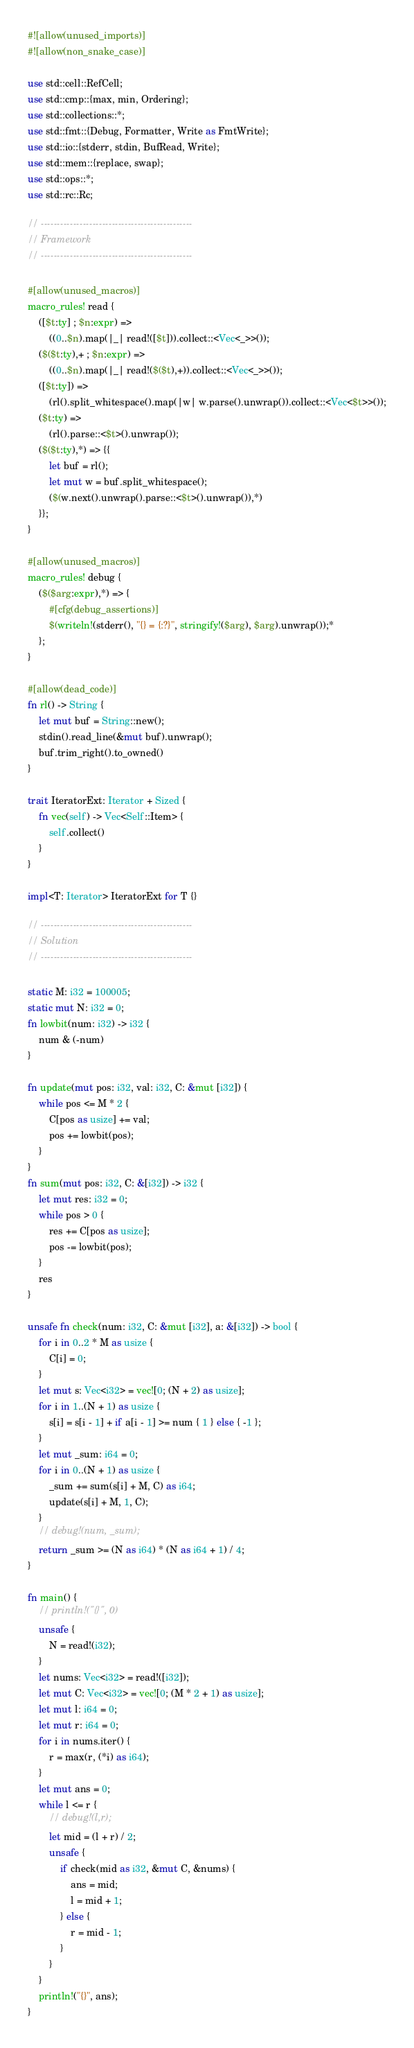<code> <loc_0><loc_0><loc_500><loc_500><_Rust_>#![allow(unused_imports)]
#![allow(non_snake_case)]

use std::cell::RefCell;
use std::cmp::{max, min, Ordering};
use std::collections::*;
use std::fmt::{Debug, Formatter, Write as FmtWrite};
use std::io::{stderr, stdin, BufRead, Write};
use std::mem::{replace, swap};
use std::ops::*;
use std::rc::Rc;

// -----------------------------------------------
// Framework
// -----------------------------------------------

#[allow(unused_macros)]
macro_rules! read {
    ([$t:ty] ; $n:expr) =>
        ((0..$n).map(|_| read!([$t])).collect::<Vec<_>>());
    ($($t:ty),+ ; $n:expr) =>
        ((0..$n).map(|_| read!($($t),+)).collect::<Vec<_>>());
    ([$t:ty]) =>
        (rl().split_whitespace().map(|w| w.parse().unwrap()).collect::<Vec<$t>>());
    ($t:ty) =>
        (rl().parse::<$t>().unwrap());
    ($($t:ty),*) => {{
        let buf = rl();
        let mut w = buf.split_whitespace();
        ($(w.next().unwrap().parse::<$t>().unwrap()),*)
    }};
}

#[allow(unused_macros)]
macro_rules! debug {
    ($($arg:expr),*) => {
        #[cfg(debug_assertions)]
        $(writeln!(stderr(), "{} = {:?}", stringify!($arg), $arg).unwrap());*
    };
}

#[allow(dead_code)]
fn rl() -> String {
    let mut buf = String::new();
    stdin().read_line(&mut buf).unwrap();
    buf.trim_right().to_owned()
}

trait IteratorExt: Iterator + Sized {
    fn vec(self) -> Vec<Self::Item> {
        self.collect()
    }
}

impl<T: Iterator> IteratorExt for T {}

// -----------------------------------------------
// Solution
// -----------------------------------------------

static M: i32 = 100005;
static mut N: i32 = 0;
fn lowbit(num: i32) -> i32 {
    num & (-num)
}

fn update(mut pos: i32, val: i32, C: &mut [i32]) {
    while pos <= M * 2 {
        C[pos as usize] += val;
        pos += lowbit(pos);
    }
}
fn sum(mut pos: i32, C: &[i32]) -> i32 {
    let mut res: i32 = 0;
    while pos > 0 {
        res += C[pos as usize];
        pos -= lowbit(pos);
    }
    res
}

unsafe fn check(num: i32, C: &mut [i32], a: &[i32]) -> bool {
    for i in 0..2 * M as usize {
        C[i] = 0;
    }
    let mut s: Vec<i32> = vec![0; (N + 2) as usize];
    for i in 1..(N + 1) as usize {
        s[i] = s[i - 1] + if a[i - 1] >= num { 1 } else { -1 };
    }
    let mut _sum: i64 = 0;
    for i in 0..(N + 1) as usize {
        _sum += sum(s[i] + M, C) as i64;
        update(s[i] + M, 1, C);
    }
    // debug!(num, _sum);
    return _sum >= (N as i64) * (N as i64 + 1) / 4;
}

fn main() {
    // println!("{}", 0)
    unsafe {
        N = read!(i32);
    }
    let nums: Vec<i32> = read!([i32]);
    let mut C: Vec<i32> = vec![0; (M * 2 + 1) as usize];
    let mut l: i64 = 0;
    let mut r: i64 = 0;
    for i in nums.iter() {
        r = max(r, (*i) as i64);
    }
    let mut ans = 0;
    while l <= r {
        // debug!(l,r);
        let mid = (l + r) / 2;
        unsafe {
            if check(mid as i32, &mut C, &nums) {
                ans = mid;
                l = mid + 1;
            } else {
                r = mid - 1;
            }
        }
    }
    println!("{}", ans);
}
</code> 